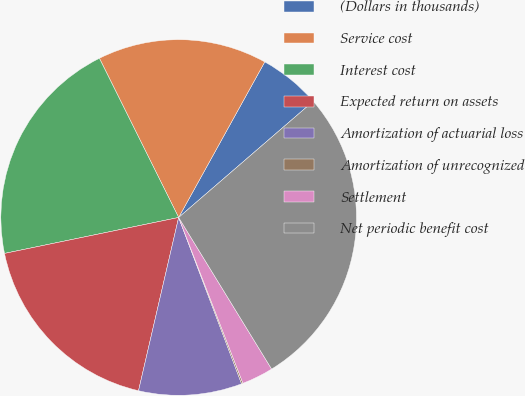Convert chart to OTSL. <chart><loc_0><loc_0><loc_500><loc_500><pie_chart><fcel>(Dollars in thousands)<fcel>Service cost<fcel>Interest cost<fcel>Expected return on assets<fcel>Amortization of actuarial loss<fcel>Amortization of unrecognized<fcel>Settlement<fcel>Net periodic benefit cost<nl><fcel>5.62%<fcel>15.4%<fcel>20.89%<fcel>18.14%<fcel>9.38%<fcel>0.13%<fcel>2.87%<fcel>27.58%<nl></chart> 